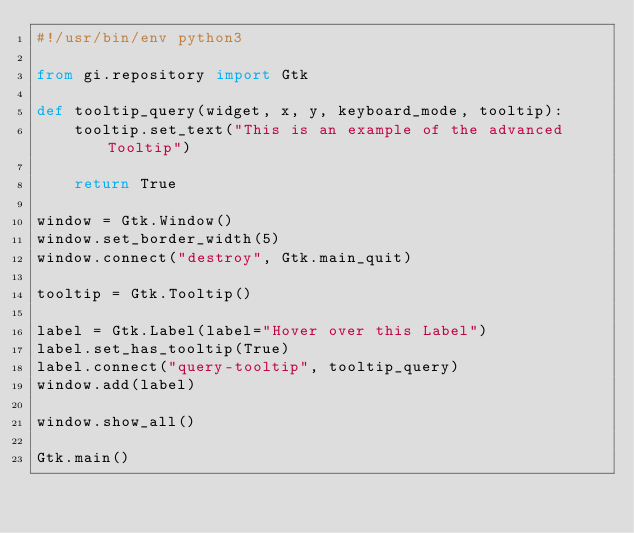Convert code to text. <code><loc_0><loc_0><loc_500><loc_500><_Python_>#!/usr/bin/env python3

from gi.repository import Gtk

def tooltip_query(widget, x, y, keyboard_mode, tooltip):
    tooltip.set_text("This is an example of the advanced Tooltip")

    return True

window = Gtk.Window()
window.set_border_width(5)
window.connect("destroy", Gtk.main_quit)

tooltip = Gtk.Tooltip()

label = Gtk.Label(label="Hover over this Label")
label.set_has_tooltip(True)
label.connect("query-tooltip", tooltip_query)
window.add(label)

window.show_all()

Gtk.main()
</code> 